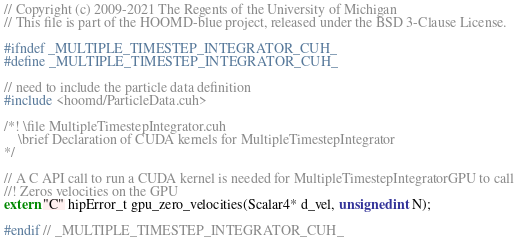<code> <loc_0><loc_0><loc_500><loc_500><_Cuda_>// Copyright (c) 2009-2021 The Regents of the University of Michigan
// This file is part of the HOOMD-blue project, released under the BSD 3-Clause License.

#ifndef _MULTIPLE_TIMESTEP_INTEGRATOR_CUH_
#define _MULTIPLE_TIMESTEP_INTEGRATOR_CUH_

// need to include the particle data definition
#include <hoomd/ParticleData.cuh>

/*! \file MultipleTimestepIntegrator.cuh
    \brief Declaration of CUDA kernels for MultipleTimestepIntegrator
*/

// A C API call to run a CUDA kernel is needed for MultipleTimestepIntegratorGPU to call
//! Zeros velocities on the GPU
extern "C" hipError_t gpu_zero_velocities(Scalar4* d_vel, unsigned int N);

#endif // _MULTIPLE_TIMESTEP_INTEGRATOR_CUH_
</code> 